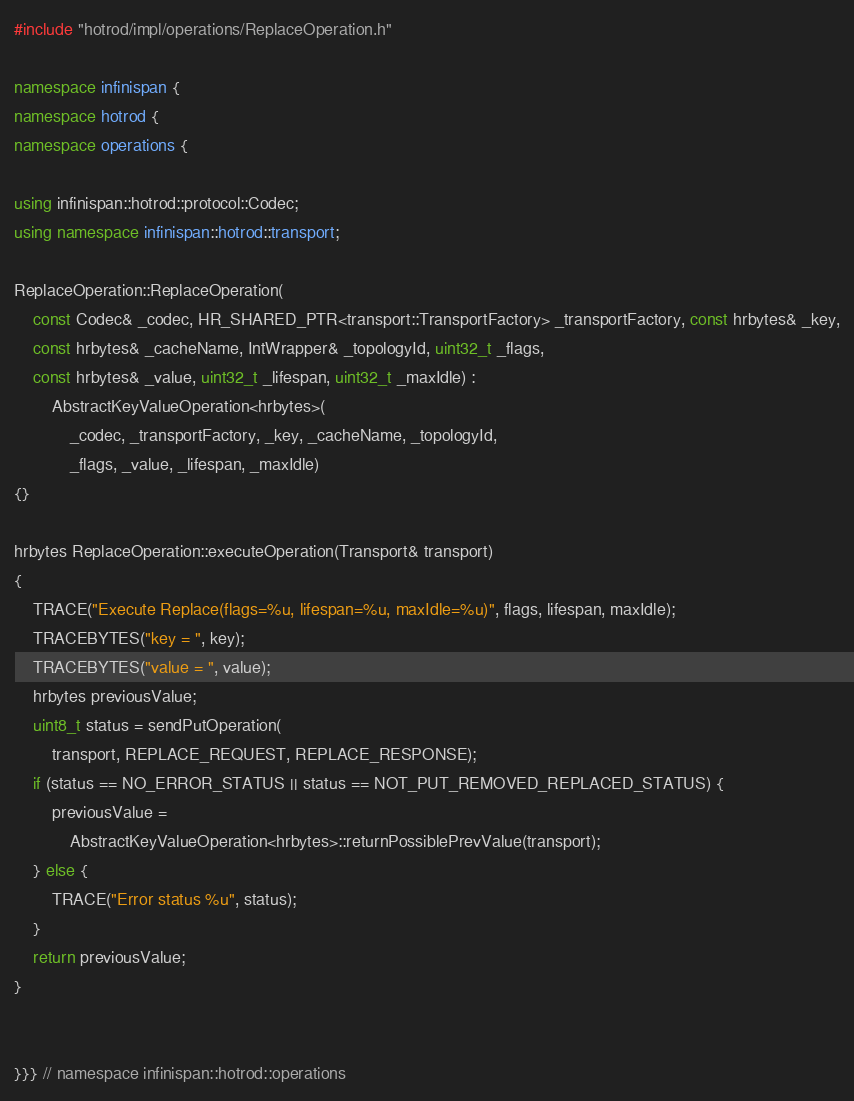Convert code to text. <code><loc_0><loc_0><loc_500><loc_500><_C++_>#include "hotrod/impl/operations/ReplaceOperation.h"

namespace infinispan {
namespace hotrod {
namespace operations {

using infinispan::hotrod::protocol::Codec;
using namespace infinispan::hotrod::transport;

ReplaceOperation::ReplaceOperation(
    const Codec& _codec, HR_SHARED_PTR<transport::TransportFactory> _transportFactory, const hrbytes& _key,
    const hrbytes& _cacheName, IntWrapper& _topologyId, uint32_t _flags,
    const hrbytes& _value, uint32_t _lifespan, uint32_t _maxIdle) :
        AbstractKeyValueOperation<hrbytes>(
            _codec, _transportFactory, _key, _cacheName, _topologyId,
            _flags, _value, _lifespan, _maxIdle)
{}

hrbytes ReplaceOperation::executeOperation(Transport& transport)
{
    TRACE("Execute Replace(flags=%u, lifespan=%u, maxIdle=%u)", flags, lifespan, maxIdle);
    TRACEBYTES("key = ", key);
    TRACEBYTES("value = ", value);
    hrbytes previousValue;
    uint8_t status = sendPutOperation(
        transport, REPLACE_REQUEST, REPLACE_RESPONSE);
    if (status == NO_ERROR_STATUS || status == NOT_PUT_REMOVED_REPLACED_STATUS) {
        previousValue =
            AbstractKeyValueOperation<hrbytes>::returnPossiblePrevValue(transport);
    } else {
        TRACE("Error status %u", status);
    }
    return previousValue;
}


}}} // namespace infinispan::hotrod::operations
</code> 